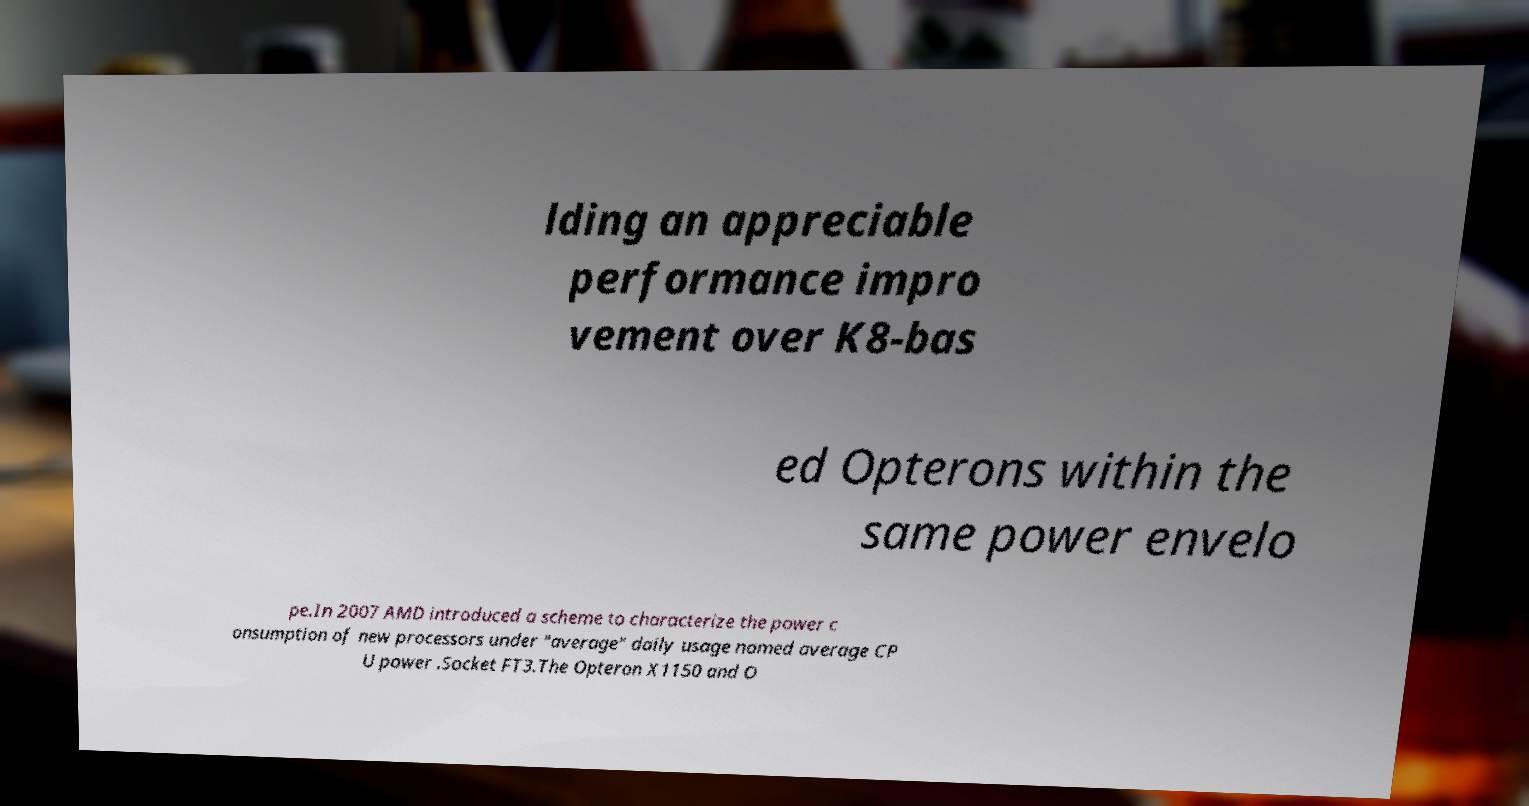Could you assist in decoding the text presented in this image and type it out clearly? lding an appreciable performance impro vement over K8-bas ed Opterons within the same power envelo pe.In 2007 AMD introduced a scheme to characterize the power c onsumption of new processors under "average" daily usage named average CP U power .Socket FT3.The Opteron X1150 and O 